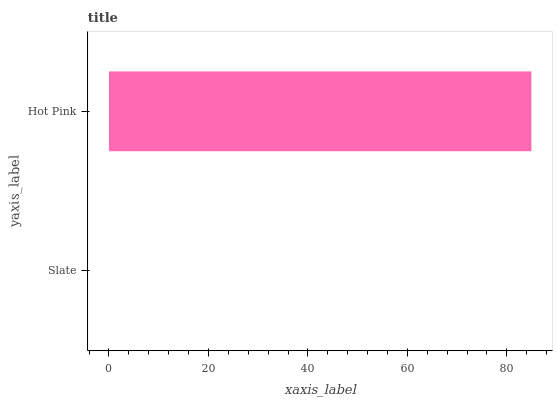Is Slate the minimum?
Answer yes or no. Yes. Is Hot Pink the maximum?
Answer yes or no. Yes. Is Hot Pink the minimum?
Answer yes or no. No. Is Hot Pink greater than Slate?
Answer yes or no. Yes. Is Slate less than Hot Pink?
Answer yes or no. Yes. Is Slate greater than Hot Pink?
Answer yes or no. No. Is Hot Pink less than Slate?
Answer yes or no. No. Is Hot Pink the high median?
Answer yes or no. Yes. Is Slate the low median?
Answer yes or no. Yes. Is Slate the high median?
Answer yes or no. No. Is Hot Pink the low median?
Answer yes or no. No. 